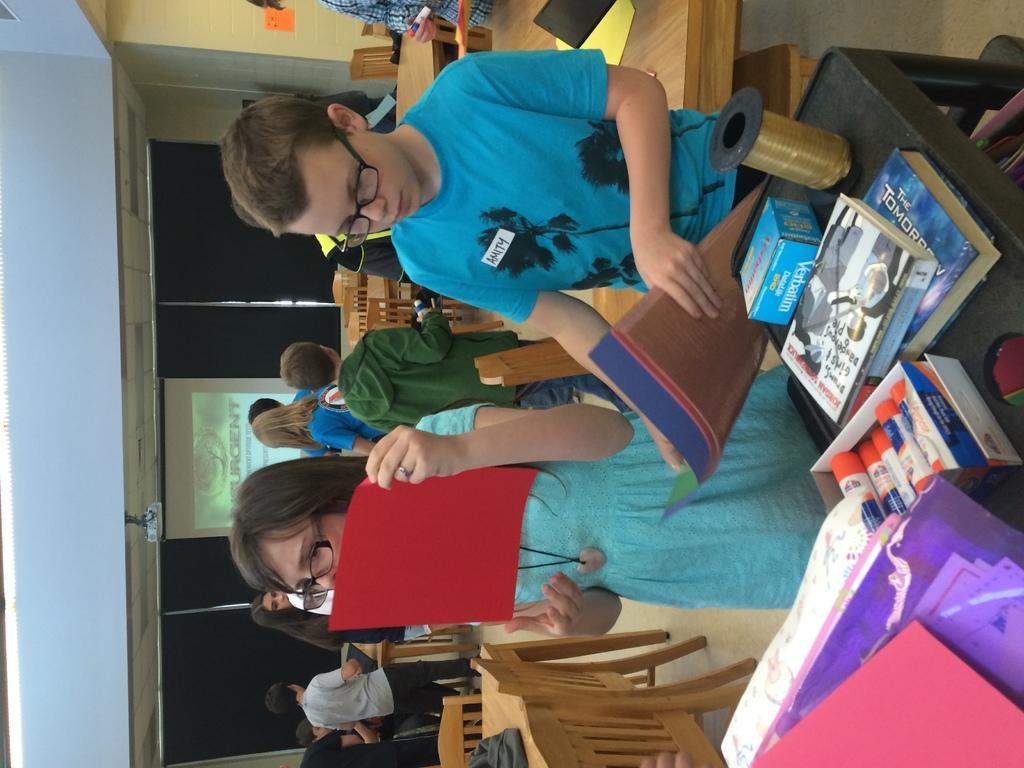Describe this image in one or two sentences. There are two pupil standing, holding some colored papers in their hands, near the table. On the table, there are some books and accessories were placed. In the background, there are some people standing. We can observe a wall here. 